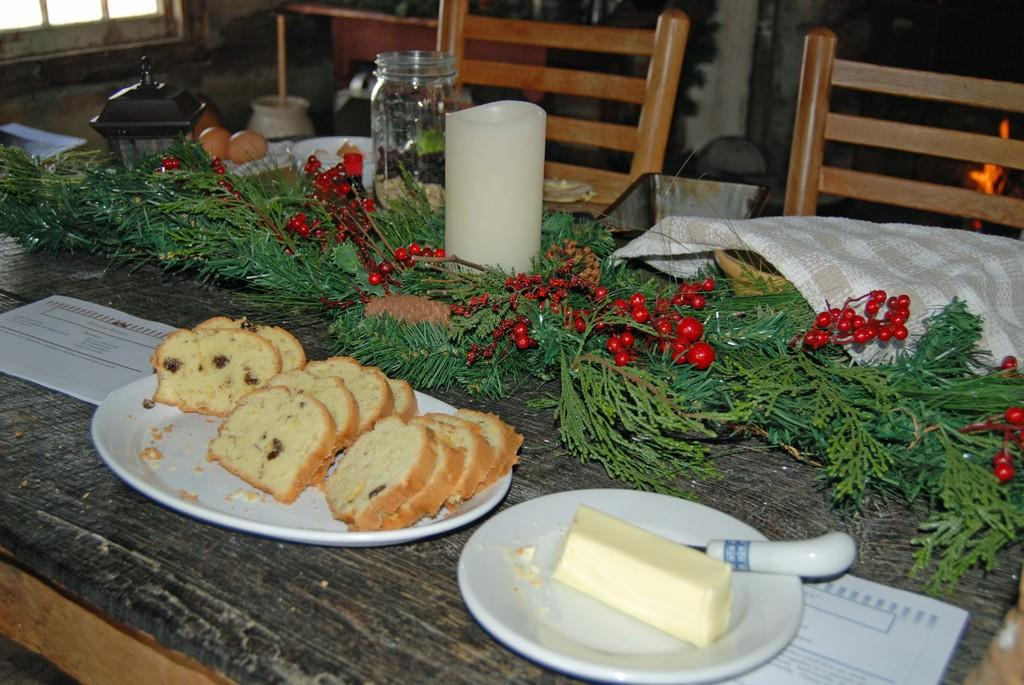Where was the image taken? The image was taken in a room. What furniture is present in the room? There is a table in the room. What can be found on the table? There are plates, food items, a knife, and a jar on the table. What is in front of the table? There are chairs in front of the table. What can be seen on the walls in the room? There is a wall in the room. What type of learning is taking place in the image? There is no indication of any learning taking place in the image; it simply shows a table with various items on it. 